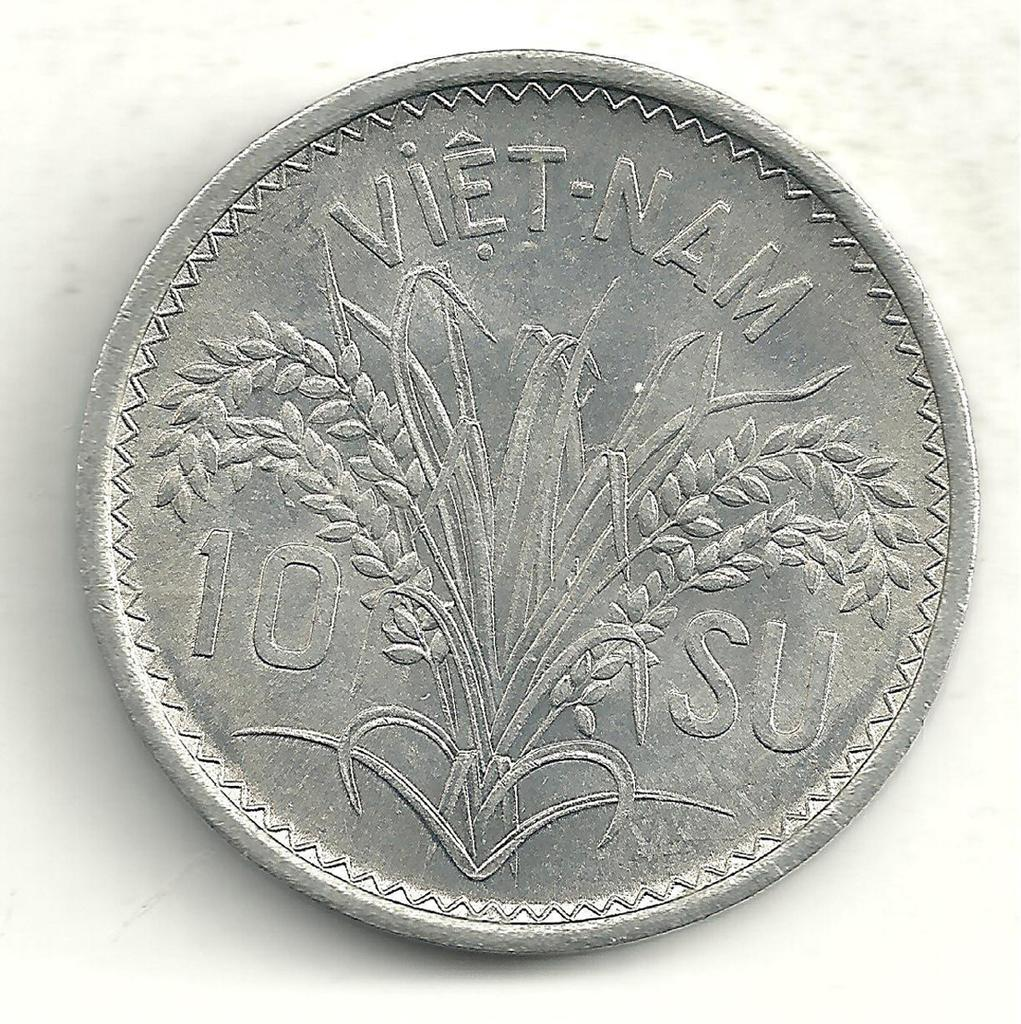What type of currency is depicted in the image? There is a currency coin of Vietnam in the image. What is the name of the sailboat in the image? There is no sailboat present in the image; it only features a currency coin of Vietnam. 